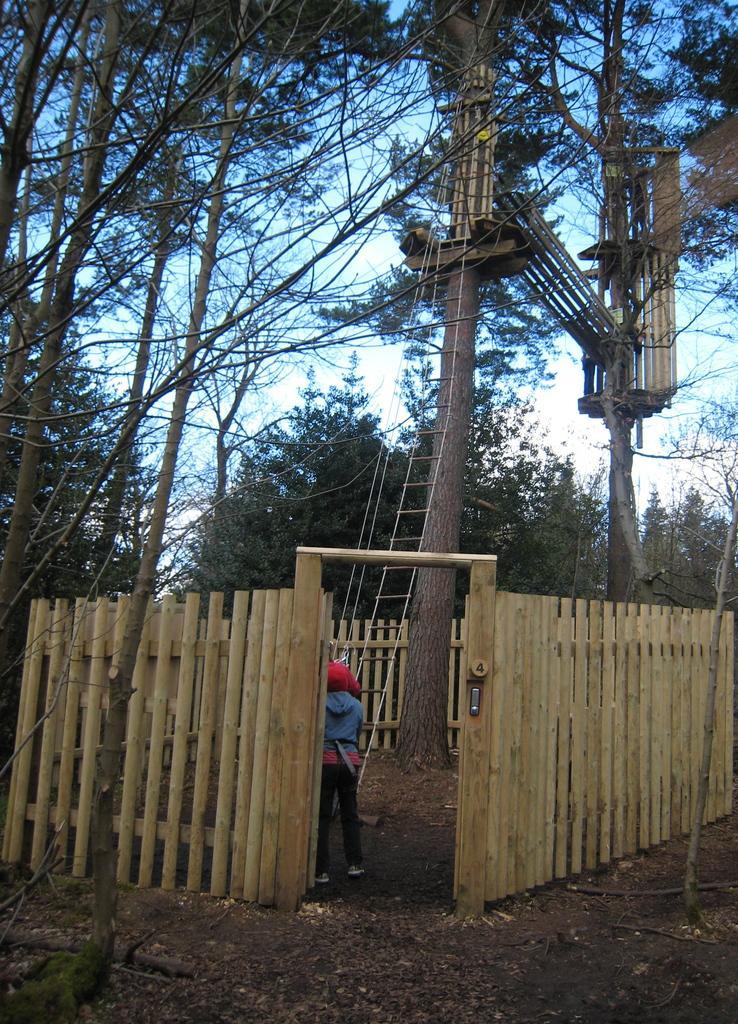Please provide a concise description of this image. In this image I can see a person standing in front of the rope ladder. I can see wooden fencing,tree-house and trees. The sky is in white color. 